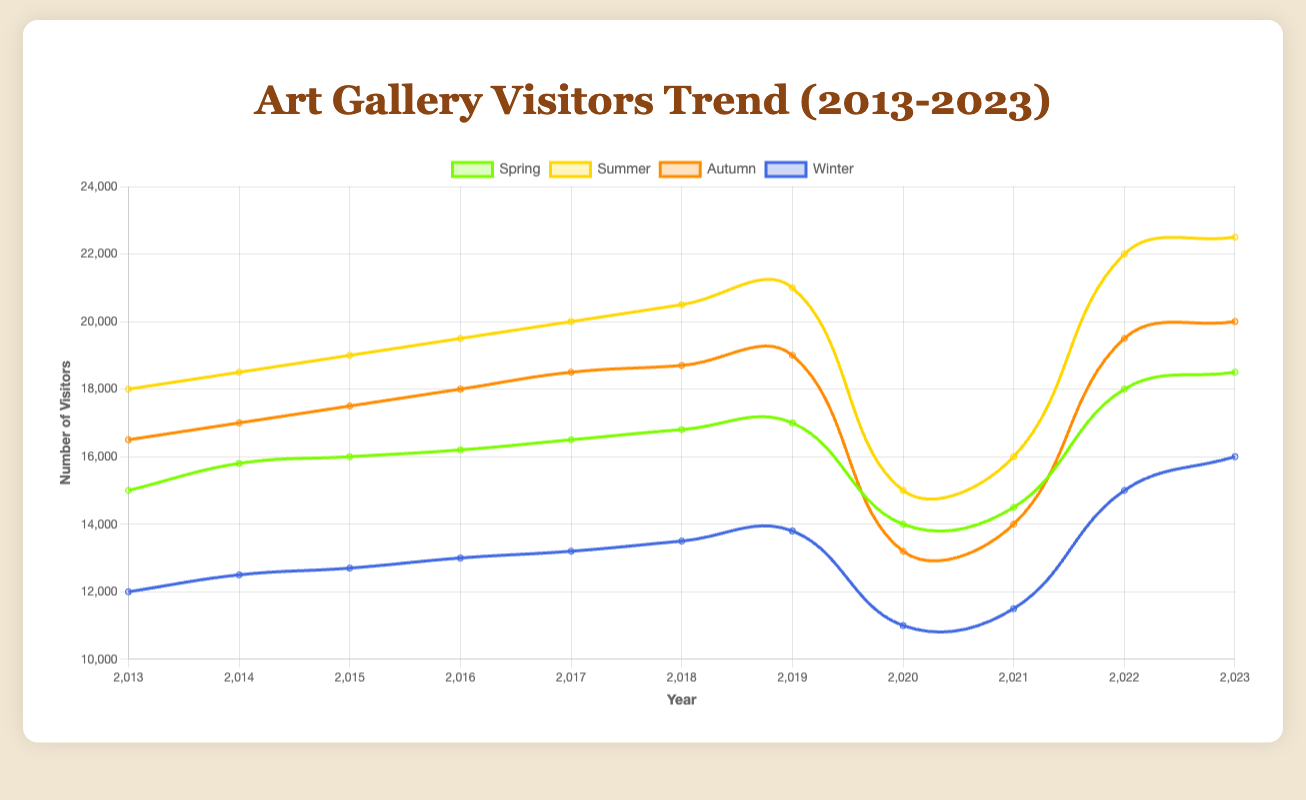What is the overall trend for summer visitors from 2013 to 2023? To determine the trend, we can look at the plotted line for summer in each year. The line shows a general upward trend with some fluctuations, peaking at 22,500 visitors in 2023.
Answer: Upward Which season had the lowest number of visitors in 2020? To find this, we compare the figures for all seasons in 2020. Spring had 14,000 visitors, Summer had 15,000, Autumn had 13,200, and Winter had 11,000. Hence, Winter had the lowest number of visitors.
Answer: Winter What is the difference in the number of visitors between Spring and Autumn in 2023? Subtract the number of Autumn visitors from the number of Spring visitors in 2023. Spring had 18,500 visitors, and Autumn had 20,000 visitors. The difference is 20,000 - 18,500.
Answer: 1,500 Which season shows the highest increase in visitors from 2021 to 2022? To find this, we calculate the increase in visitors for each season between 2021 and 2022. For Spring: 18,000 - 14,500 = 3,500. For Summer: 22,000 - 16,000 = 6,000. For Autumn: 19,500 - 14,000 = 5,500. For Winter: 15,000 - 11,500 = 3,500. Hence, Summer shows the highest increase.
Answer: Summer How many more visitors in Summer 2017 compared to Winter 2017? To answer this, subtract the number of visitors in Winter from the number of visitors in Summer for the year 2017. Summer had 20,000 visitors and Winter had 13,200 visitors. So, 20,000 - 13,200.
Answer: 6,800 What was the average number of visitors in Spring over the decade 2013-2023? Add the number of visitors for Spring from each year and divide by the number of years (11). (15,000 + 15,800 + 16,000 + 16,200 + 16,500 + 16,800 + 17,000 + 14,000 + 14,500 + 18,000 + 18,500) / 11.
Answer: 16,091 Compare the number of visitors in Autumn 2019 to Autumn 2020. Which year had more visitors? Look at the visitors in Autumn for both years. In 2019, there were 19,000 visitors, and in 2020, there were 13,200 visitors. Therefore, 2019 had more visitors.
Answer: 2019 What can be concluded about the trend for Winter visitors from 2013 to 2023? Examine the line for Winter visitors across the years. There is a general downward trend with the lowest point at 11,000 visitors in 2020, followed by a slight recovery up to 16,000 visitors in 2023. Overall, there is a decrease followed by recent growth.
Answer: General decrease followed by growth Which season had the most visitors overall in any single year, and what was that number? Examine the maximum visitors in each season across all years. Summer 2023 had the maximum number of visitors, peaking at 22,500.
Answer: Summer 2023, 22,500 What is the difference in the number of visitors between the peak year for Summer and the lowest year for Winter? The peak year for Summer is 2023 with 22,500 visitors, and the lowest year for Winter is 2020 with 11,000 visitors. The difference is 22,500 - 11,000.
Answer: 11,500 